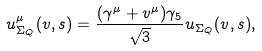Convert formula to latex. <formula><loc_0><loc_0><loc_500><loc_500>u _ { \Sigma _ { Q } } ^ { \mu } ( v , s ) = \frac { ( \gamma ^ { \mu } + v ^ { \mu } ) \gamma _ { 5 } } { \sqrt { 3 } } u _ { \Sigma _ { Q } } ( v , s ) ,</formula> 